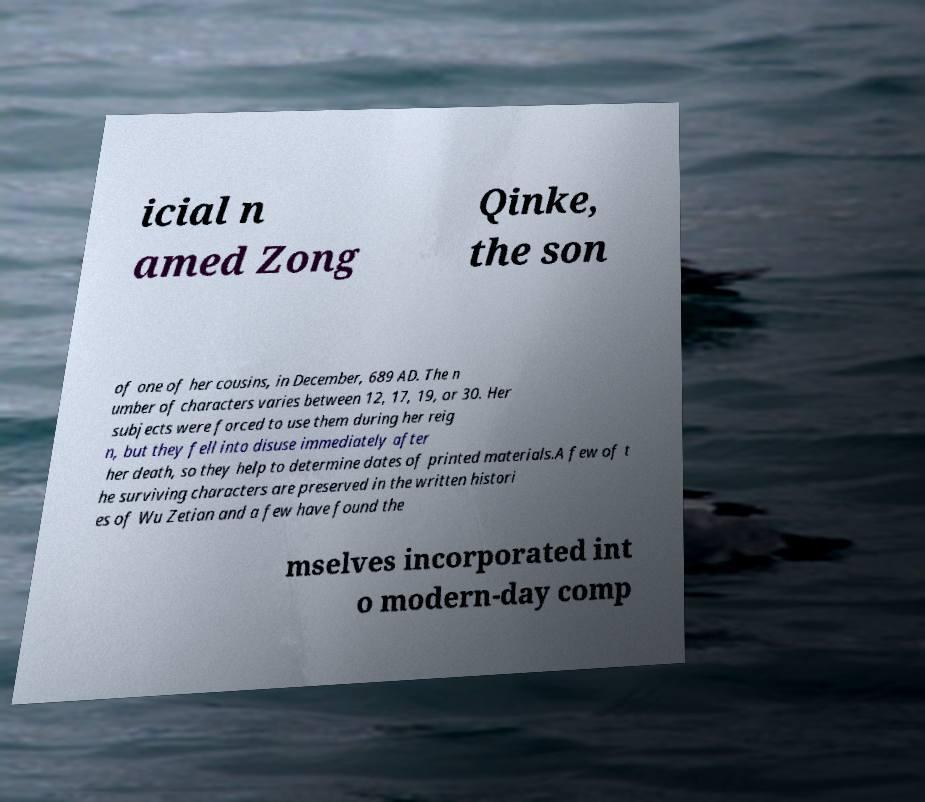For documentation purposes, I need the text within this image transcribed. Could you provide that? icial n amed Zong Qinke, the son of one of her cousins, in December, 689 AD. The n umber of characters varies between 12, 17, 19, or 30. Her subjects were forced to use them during her reig n, but they fell into disuse immediately after her death, so they help to determine dates of printed materials.A few of t he surviving characters are preserved in the written histori es of Wu Zetian and a few have found the mselves incorporated int o modern-day comp 